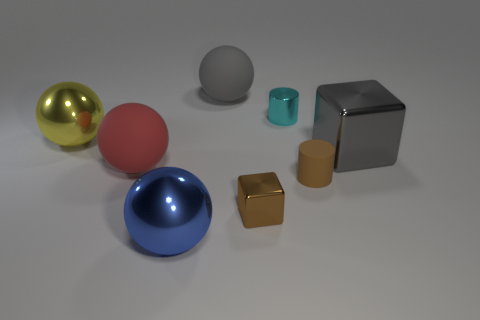Subtract all yellow balls. How many balls are left? 3 Subtract all yellow balls. How many balls are left? 3 Subtract all brown spheres. Subtract all gray cylinders. How many spheres are left? 4 Subtract all cylinders. How many objects are left? 6 Add 1 gray rubber spheres. How many objects exist? 9 Add 4 gray balls. How many gray balls are left? 5 Add 5 tiny cyan objects. How many tiny cyan objects exist? 6 Subtract 0 green balls. How many objects are left? 8 Subtract all big green shiny cubes. Subtract all large metal blocks. How many objects are left? 7 